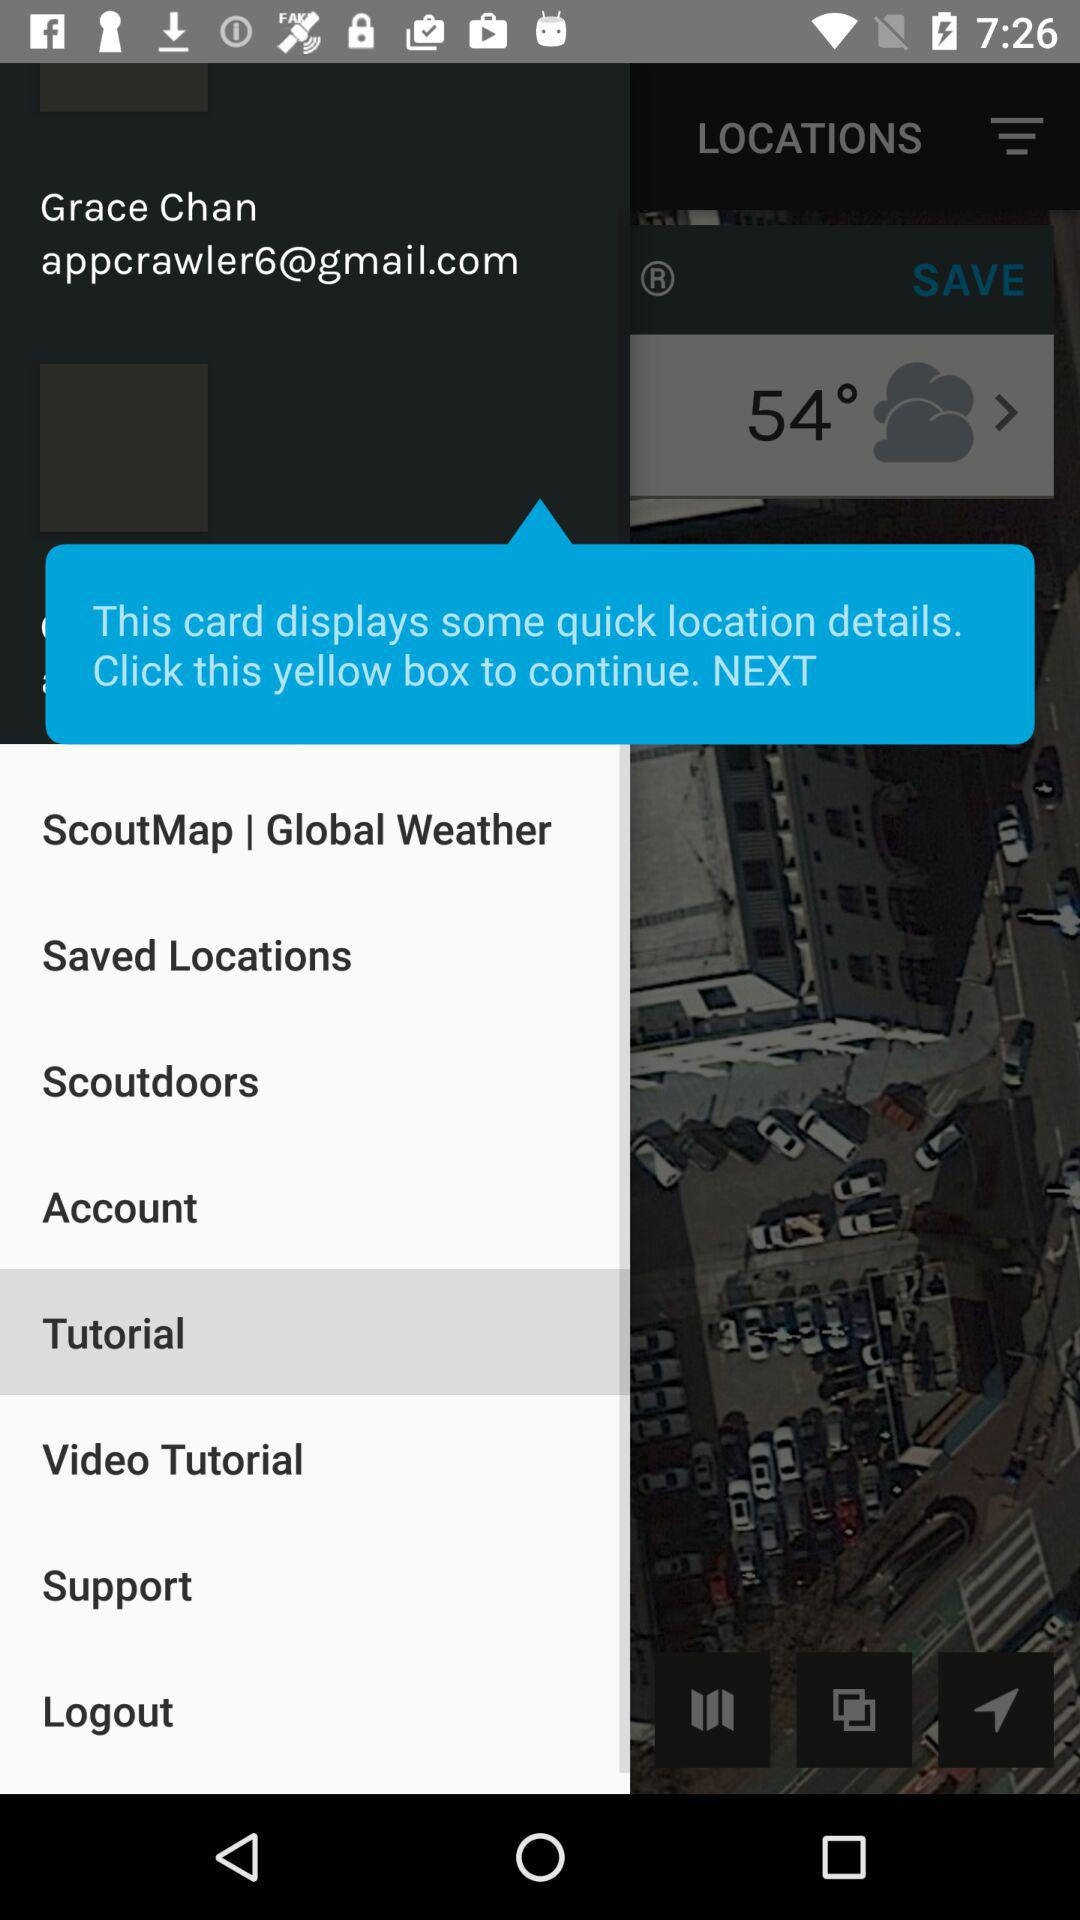What is the user name? The user name is Grace Chan. 